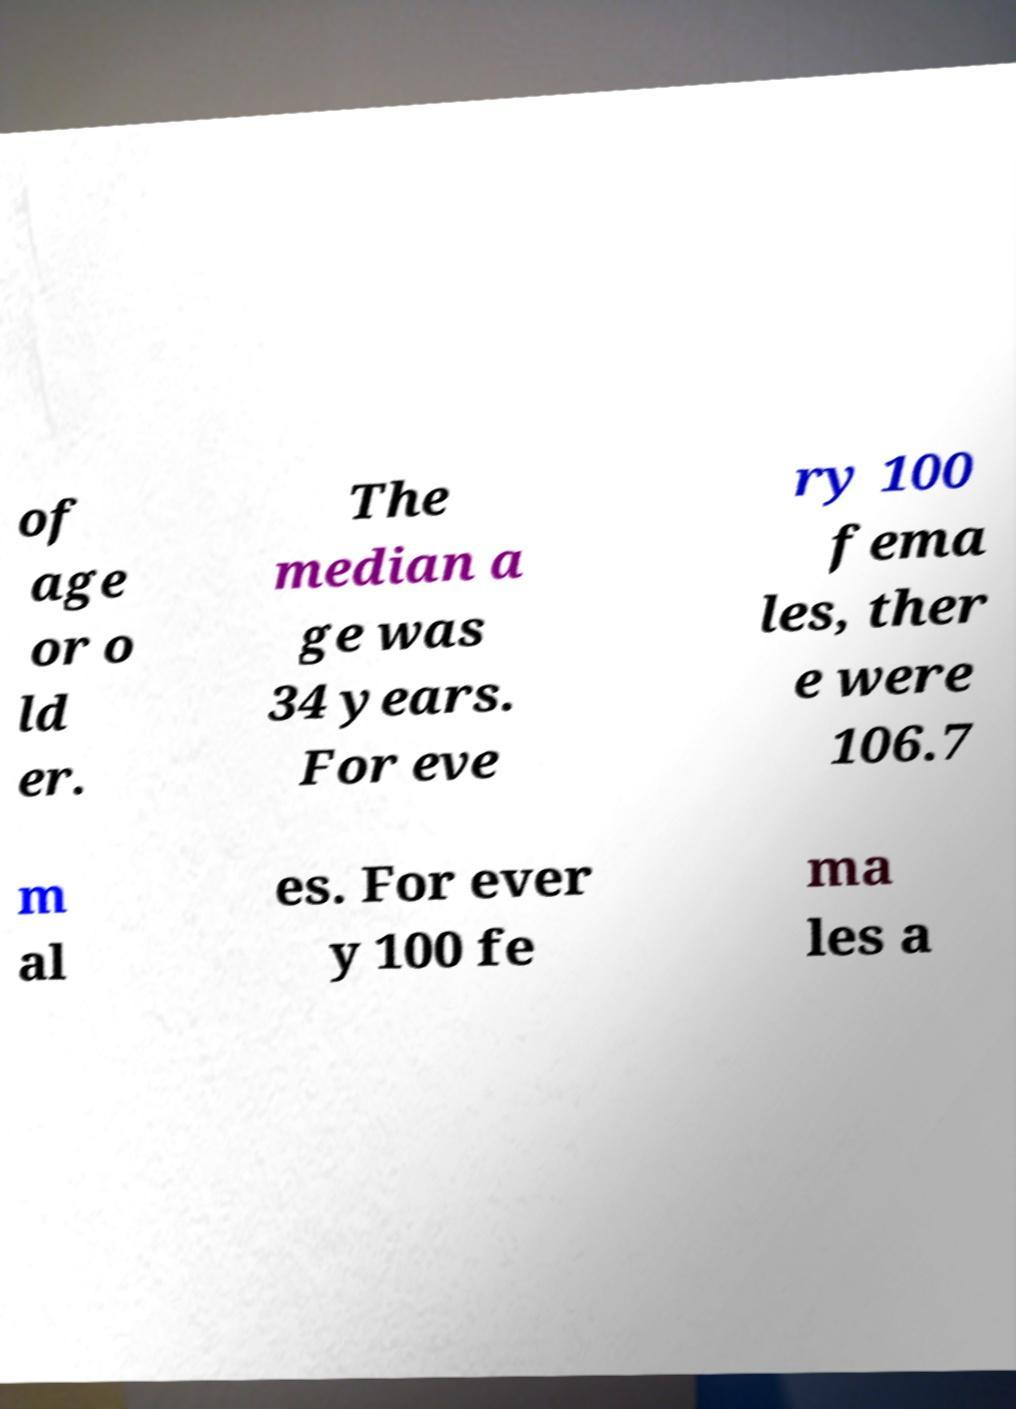Could you assist in decoding the text presented in this image and type it out clearly? of age or o ld er. The median a ge was 34 years. For eve ry 100 fema les, ther e were 106.7 m al es. For ever y 100 fe ma les a 